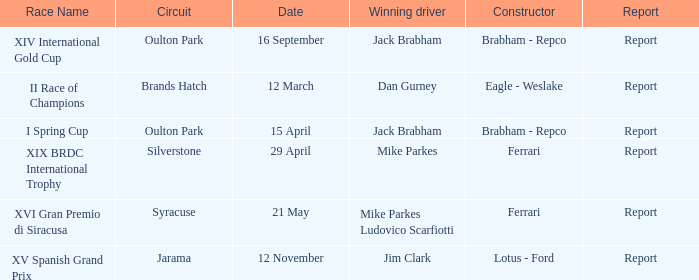What company constrcuted the vehicle with a circuit of oulton park on 15 april? Brabham - Repco. 